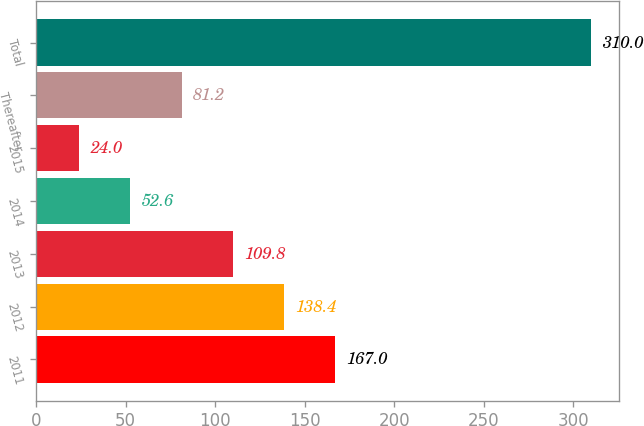<chart> <loc_0><loc_0><loc_500><loc_500><bar_chart><fcel>2011<fcel>2012<fcel>2013<fcel>2014<fcel>2015<fcel>Thereafter<fcel>Total<nl><fcel>167<fcel>138.4<fcel>109.8<fcel>52.6<fcel>24<fcel>81.2<fcel>310<nl></chart> 